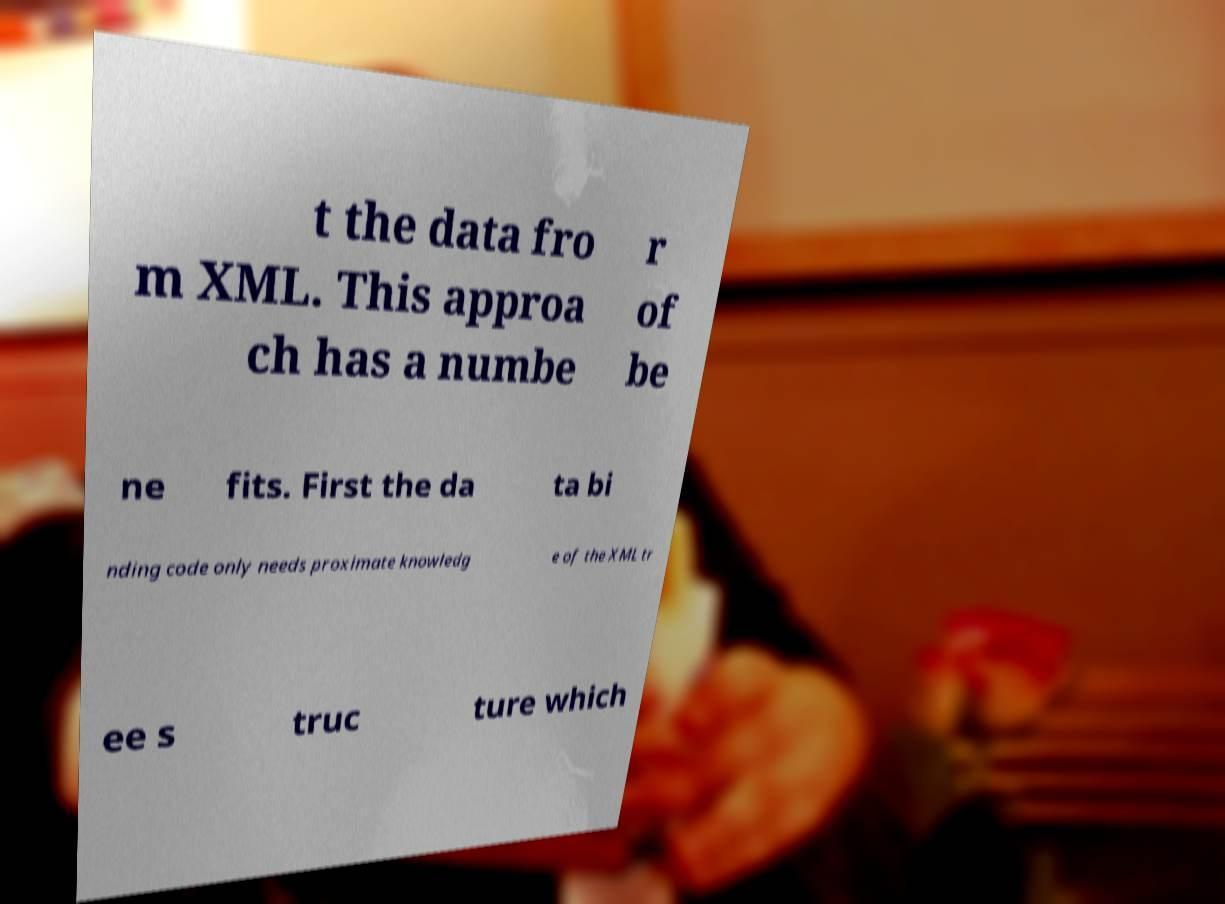Can you accurately transcribe the text from the provided image for me? t the data fro m XML. This approa ch has a numbe r of be ne fits. First the da ta bi nding code only needs proximate knowledg e of the XML tr ee s truc ture which 